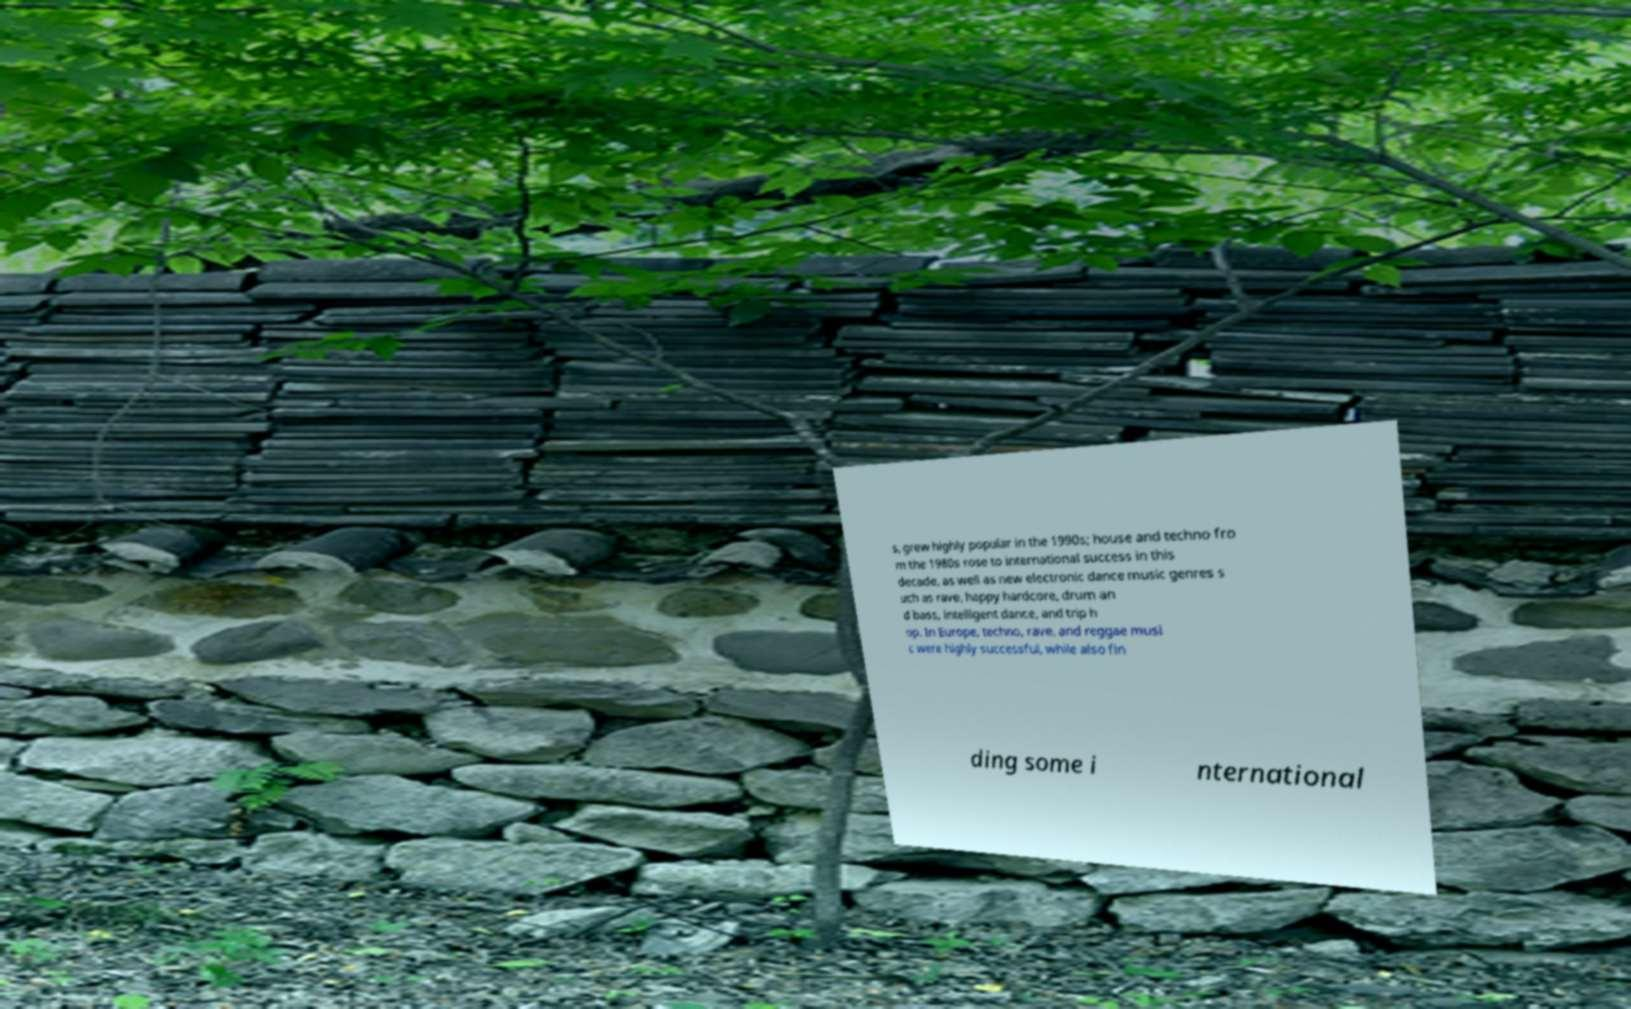Can you accurately transcribe the text from the provided image for me? s, grew highly popular in the 1990s; house and techno fro m the 1980s rose to international success in this decade, as well as new electronic dance music genres s uch as rave, happy hardcore, drum an d bass, intelligent dance, and trip h op. In Europe, techno, rave, and reggae musi c were highly successful, while also fin ding some i nternational 